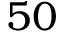<formula> <loc_0><loc_0><loc_500><loc_500>5 0</formula> 